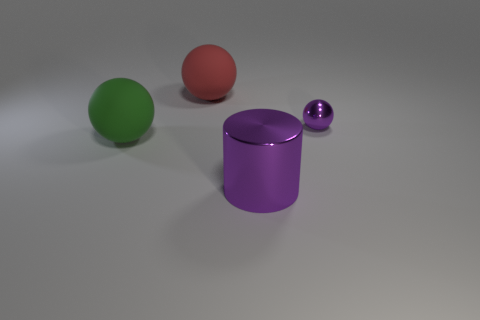There is a matte sphere that is behind the purple thing to the right of the large shiny thing; is there a big red rubber sphere behind it?
Give a very brief answer. No. How many rubber objects are either large things or cylinders?
Offer a very short reply. 2. Is the tiny ball the same color as the shiny cylinder?
Provide a short and direct response. Yes. There is a big red ball; what number of small purple metallic things are left of it?
Ensure brevity in your answer.  0. How many things are on the right side of the cylinder and to the left of the purple shiny sphere?
Make the answer very short. 0. The other purple thing that is the same material as the small purple thing is what shape?
Provide a succinct answer. Cylinder. There is a rubber ball that is in front of the small purple metallic object; does it have the same size as the cylinder that is on the right side of the big green ball?
Your answer should be very brief. Yes. There is a metal object behind the purple cylinder; what color is it?
Your response must be concise. Purple. What is the purple object that is in front of the purple object that is behind the green rubber thing made of?
Make the answer very short. Metal. What is the shape of the big purple object?
Your answer should be compact. Cylinder. 